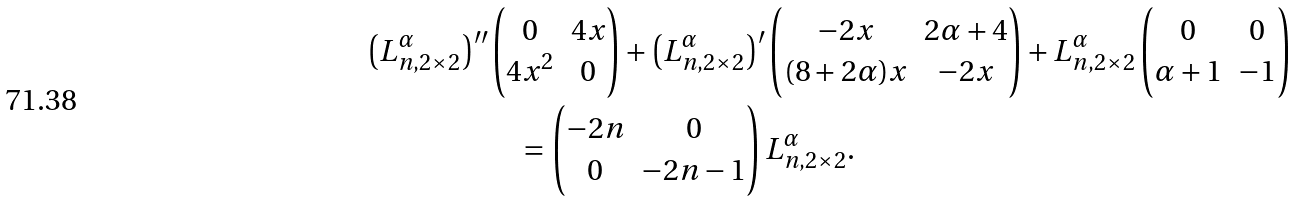Convert formula to latex. <formula><loc_0><loc_0><loc_500><loc_500>\left ( L ^ { \alpha } _ { n , 2 \times 2 } \right ) ^ { \prime \prime } & \begin{pmatrix} 0 & 4 x \\ 4 x ^ { 2 } & 0 \end{pmatrix} + \left ( L ^ { \alpha } _ { n , 2 \times 2 } \right ) ^ { \prime } \begin{pmatrix} - 2 x & 2 \alpha + 4 \\ ( 8 + 2 \alpha ) x & - 2 x \end{pmatrix} + L ^ { \alpha } _ { n , 2 \times 2 } \begin{pmatrix} 0 & 0 \\ \alpha + 1 & - 1 \end{pmatrix} \\ & \quad = \begin{pmatrix} - 2 n & 0 \\ 0 & - 2 n - 1 \end{pmatrix} L ^ { \alpha } _ { n , 2 \times 2 } .</formula> 